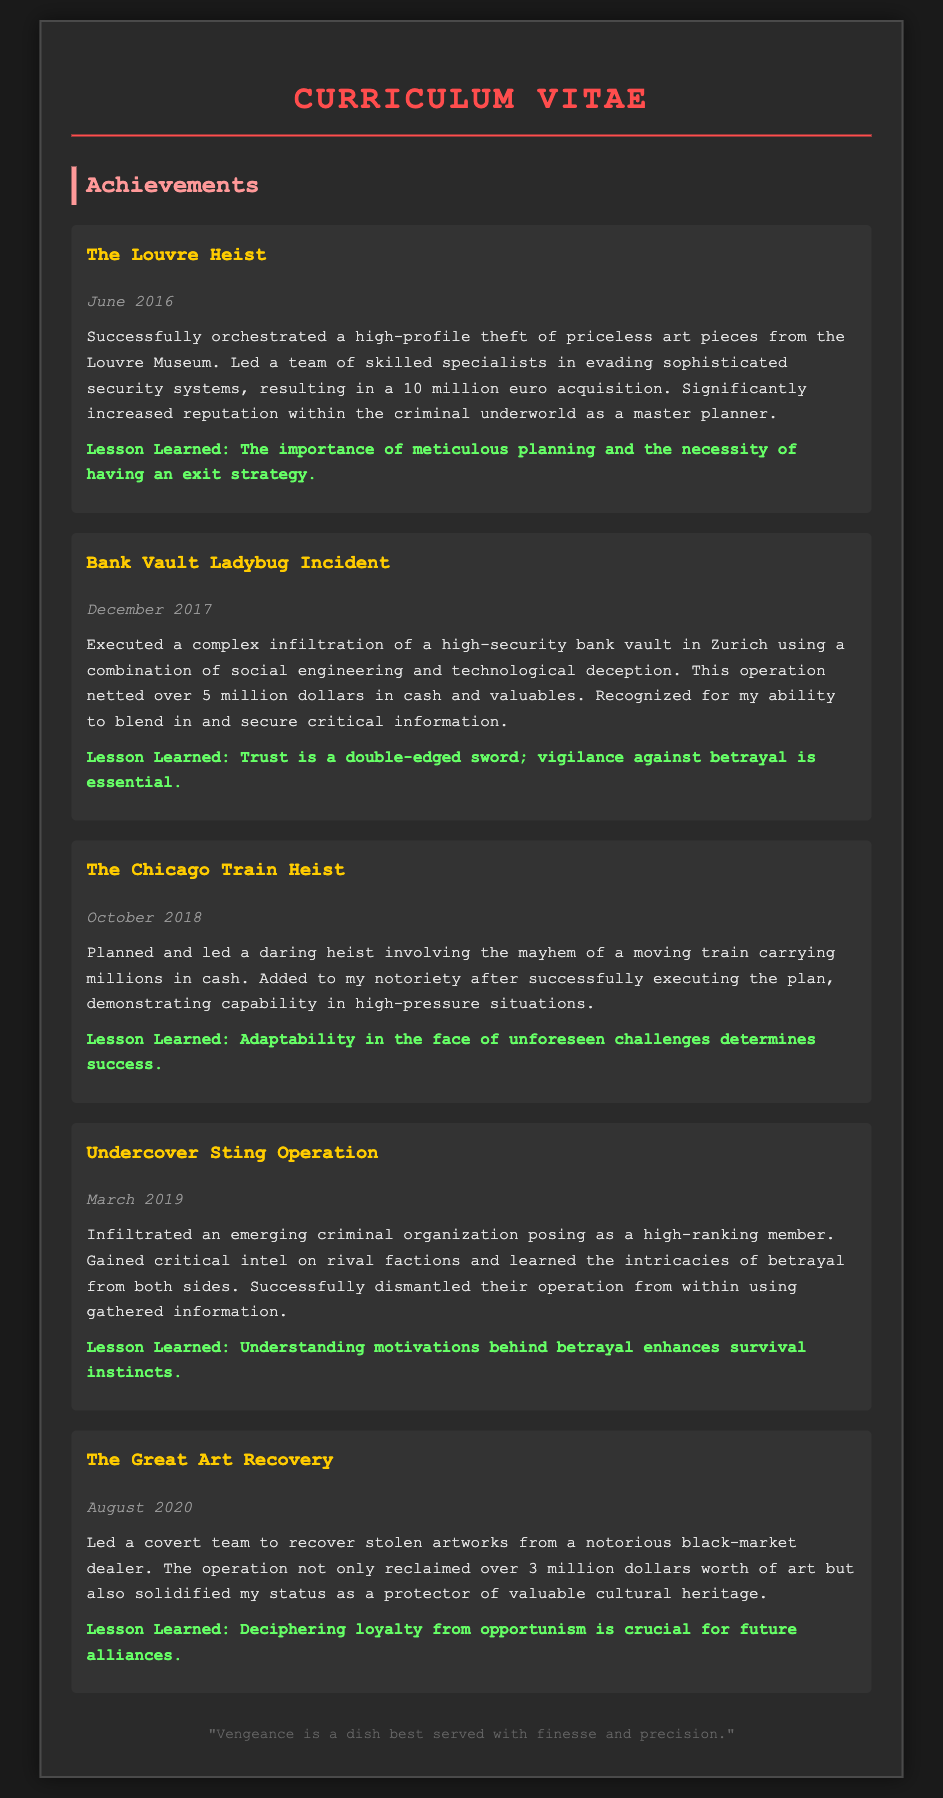What was the date of The Louvre Heist? The date of The Louvre Heist is explicitly stated in the document under the description of the achievement.
Answer: June 2016 How much was acquired from the Bank Vault Ladybug Incident? The document provides the total amount acquired from this operation, which is specified in the text.
Answer: over 5 million dollars What was the main lesson learned from the Chicago Train Heist? The lesson learned is mentioned directly in the description of the Chicago Train Heist in the document.
Answer: Adaptability in the face of unforeseen challenges determines success What operation helped solidify their status as a protector? The document refers to a specific operation that led to this recognition.
Answer: The Great Art Recovery Which achievement involved infiltrating a criminal organization? The document details a specific achievement regarding infiltration of an organization.
Answer: Undercover Sting Operation What notable figure was associated with the achievements? The document contains references to the individual behind the achievements, but does not provide a specific name; however, it's implied through the context.
Answer: Vengeful Ex-Associate 